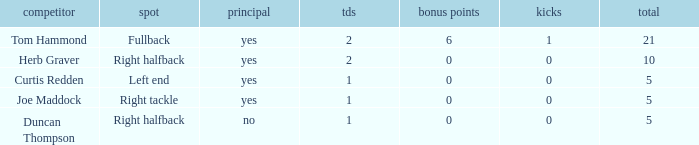Name the most touchdowns for field goals being 1 2.0. 